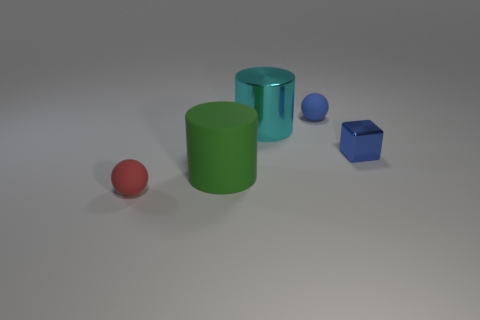Add 4 tiny blue matte balls. How many objects exist? 9 Subtract all cylinders. How many objects are left? 3 Subtract 1 cubes. How many cubes are left? 0 Add 2 small shiny objects. How many small shiny objects exist? 3 Subtract 1 cyan cylinders. How many objects are left? 4 Subtract all purple spheres. Subtract all purple cubes. How many spheres are left? 2 Subtract all big gray cubes. Subtract all metallic objects. How many objects are left? 3 Add 2 metallic cubes. How many metallic cubes are left? 3 